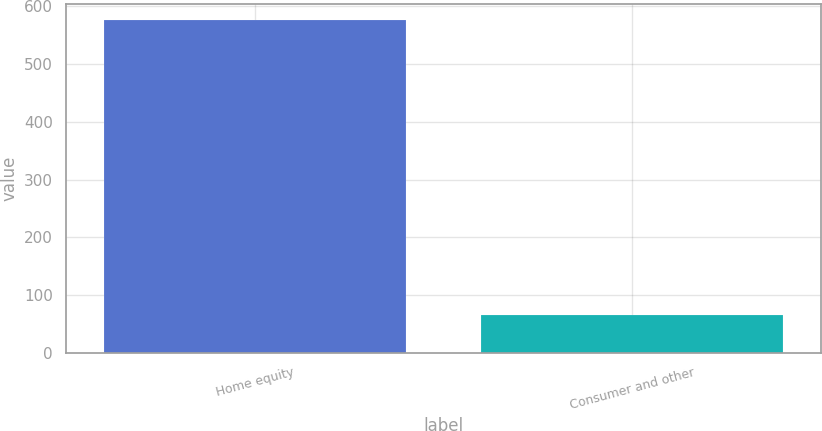Convert chart to OTSL. <chart><loc_0><loc_0><loc_500><loc_500><bar_chart><fcel>Home equity<fcel>Consumer and other<nl><fcel>576.1<fcel>65.5<nl></chart> 